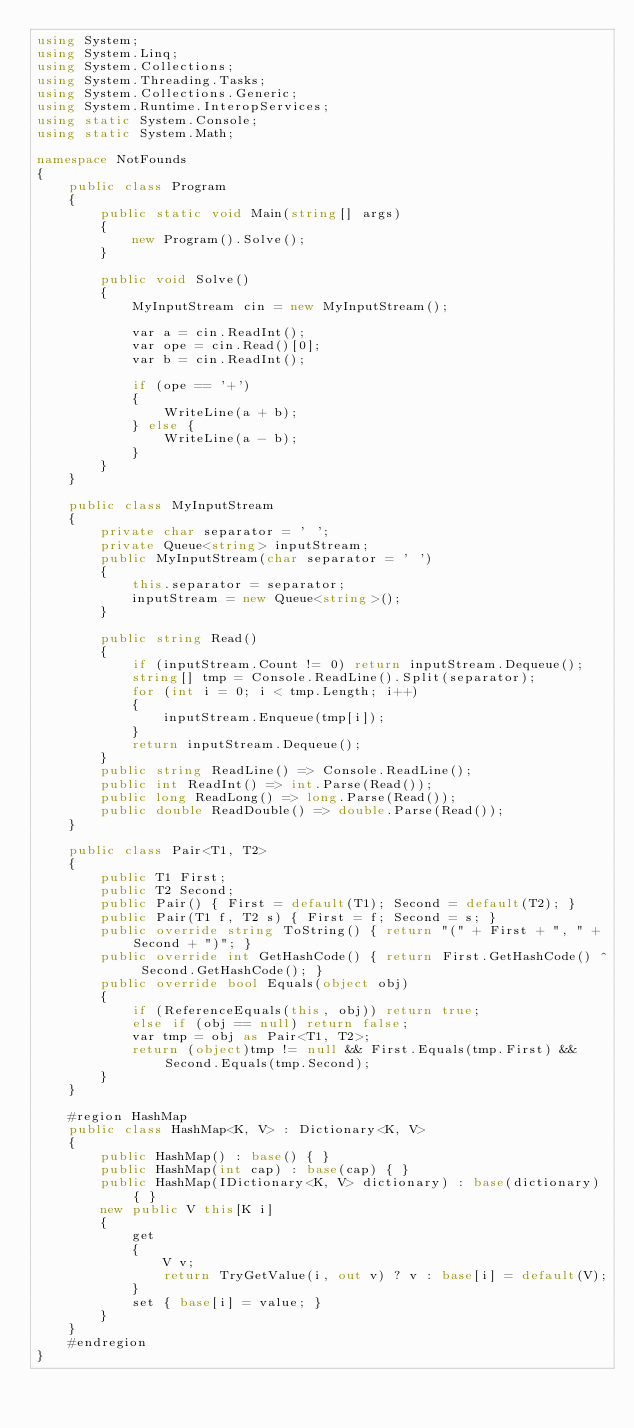Convert code to text. <code><loc_0><loc_0><loc_500><loc_500><_C#_>using System;
using System.Linq;
using System.Collections;
using System.Threading.Tasks;
using System.Collections.Generic;
using System.Runtime.InteropServices;
using static System.Console;
using static System.Math;

namespace NotFounds
{
    public class Program
    {
        public static void Main(string[] args)
        {
            new Program().Solve();
        }

        public void Solve()
        {
            MyInputStream cin = new MyInputStream();

            var a = cin.ReadInt();
            var ope = cin.Read()[0];
            var b = cin.ReadInt();

            if (ope == '+')
            {
                WriteLine(a + b);
            } else {
                WriteLine(a - b);
            }
        }
    }

    public class MyInputStream
    {
        private char separator = ' ';
        private Queue<string> inputStream;
        public MyInputStream(char separator = ' ')
        {
            this.separator = separator;
            inputStream = new Queue<string>();
        }

        public string Read()
        {
            if (inputStream.Count != 0) return inputStream.Dequeue();
            string[] tmp = Console.ReadLine().Split(separator);
            for (int i = 0; i < tmp.Length; i++)
            {
                inputStream.Enqueue(tmp[i]);
            }
            return inputStream.Dequeue();
        }
        public string ReadLine() => Console.ReadLine();
        public int ReadInt() => int.Parse(Read());
        public long ReadLong() => long.Parse(Read());
        public double ReadDouble() => double.Parse(Read());
    }

    public class Pair<T1, T2>
    {
        public T1 First;
        public T2 Second;
        public Pair() { First = default(T1); Second = default(T2); }
        public Pair(T1 f, T2 s) { First = f; Second = s; }
        public override string ToString() { return "(" + First + ", " + Second + ")"; }
        public override int GetHashCode() { return First.GetHashCode() ^ Second.GetHashCode(); }
        public override bool Equals(object obj)
        {
            if (ReferenceEquals(this, obj)) return true;
            else if (obj == null) return false;
            var tmp = obj as Pair<T1, T2>;
            return (object)tmp != null && First.Equals(tmp.First) && Second.Equals(tmp.Second);
        }
    }

    #region HashMap
    public class HashMap<K, V> : Dictionary<K, V>
    {
        public HashMap() : base() { }
        public HashMap(int cap) : base(cap) { }
        public HashMap(IDictionary<K, V> dictionary) : base(dictionary) { }
        new public V this[K i]
        {
            get
            {
                V v;
                return TryGetValue(i, out v) ? v : base[i] = default(V);
            }
            set { base[i] = value; }
        }
    }
    #endregion
}
</code> 